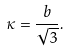Convert formula to latex. <formula><loc_0><loc_0><loc_500><loc_500>\kappa = \frac { b } { \sqrt { 3 } } .</formula> 